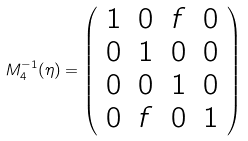Convert formula to latex. <formula><loc_0><loc_0><loc_500><loc_500>M _ { 4 } ^ { - 1 } ( \eta ) = \left ( \begin{array} { c c c c } 1 & 0 & f & 0 \\ 0 & 1 & 0 & 0 \\ 0 & 0 & 1 & 0 \\ 0 & f & 0 & 1 \\ \end{array} \right )</formula> 